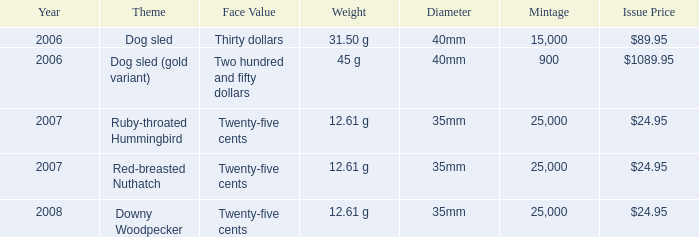What is the subject of the coin priced at $8 Dog sled. 